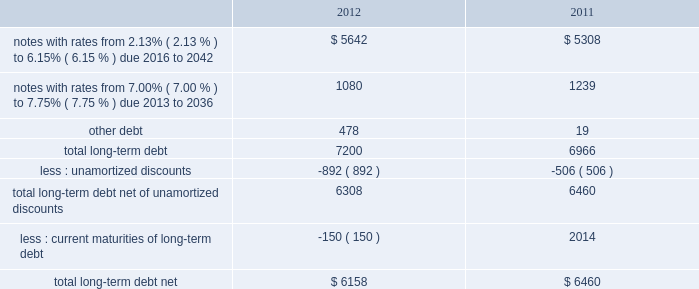Note 8 2013 debt our long-term debt consisted of the following ( in millions ) : .
In december 2012 , we issued notes totaling $ 1.3 billion with a fixed interest rate of 4.07% ( 4.07 % ) maturing in december 2042 ( the new notes ) in exchange for outstanding notes totaling $ 1.2 billion with interest rates ranging from 5.50% ( 5.50 % ) to 8.50% ( 8.50 % ) maturing in 2023 to 2040 ( the old notes ) .
In connection with the exchange , we paid a premium of $ 393 million , of which $ 225 million was paid in cash and $ 168 million was in the form of new notes .
This premium , in addition to $ 194 million in remaining unamortized discounts related to the old notes , will be amortized as additional interest expense over the term of the new notes using the effective interest method .
We may , at our option , redeem some or all of the new notes at any time by paying the principal amount of notes being redeemed plus a make-whole premium and accrued and unpaid interest .
Interest on the new notes is payable on june 15 and december 15 of each year , beginning on june 15 , 2013 .
The new notes are unsecured senior obligations and rank equally in right of payment with all of our existing and future unsecured and unsubordinated indebtedness .
On september 9 , 2011 , we issued $ 2.0 billion of long-term notes in a registered public offering consisting of $ 500 million maturing in 2016 with a fixed interest rate of 2.13% ( 2.13 % ) , $ 900 million maturing in 2021 with a fixed interest rate of 3.35% ( 3.35 % ) , and $ 600 million maturing in 2041 with a fixed interest rate of 4.85% ( 4.85 % ) .
We may , at our option , redeem some or all of the notes at any time by paying the principal amount of notes being redeemed plus a make-whole premium and accrued and unpaid interest .
Interest on the notes is payable on march 15 and september 15 of each year , beginning on march 15 , 2012 .
In october 2011 , we used a portion of the proceeds to redeem all of our $ 500 million long-term notes maturing in 2013 .
In 2011 , we repurchased $ 84 million of our long-term notes through open-market purchases .
We paid premiums of $ 48 million in connection with the early extinguishments of debt , which were recognized in other non-operating income ( expense ) , net .
In august 2011 , we entered into a $ 1.5 billion revolving credit facility with a group of banks and terminated our existing $ 1.5 billion revolving credit facility that was to expire in june 2012 .
The credit facility expires august 2016 , and we may request and the banks may grant , at their discretion , an increase to the credit facility by an additional amount up to $ 500 million .
There were no borrowings outstanding under either facility through december 31 , 2012 .
Borrowings under the credit facility would be unsecured and bear interest at rates based , at our option , on a eurodollar rate or a base rate , as defined in the credit facility .
Each bank 2019s obligation to make loans under the credit facility is subject to , among other things , our compliance with various representations , warranties and covenants , including covenants limiting our ability and certain of our subsidiaries 2019 ability to encumber assets and a covenant not to exceed a maximum leverage ratio , as defined in the credit facility .
The leverage ratio covenant excludes the adjustments recognized in stockholders 2019 equity related to postretirement benefit plans .
As of december 31 , 2012 , we were in compliance with all covenants contained in the credit facility , as well as in our debt agreements .
We have agreements in place with banking institutions to provide for the issuance of commercial paper .
There were no commercial paper borrowings outstanding during 2012 or 2011 .
If we were to issue commercial paper , the borrowings would be supported by the credit facility .
During the next five years , we have scheduled long-term debt maturities of $ 150 million due in 2013 and $ 952 million due in 2016 .
Interest payments were $ 378 million in 2012 , $ 326 million in 2011 , and $ 337 million in 2010. .
What is the percentage change in interest payments from 2011 to 2012? 
Computations: ((378 - 326) / 326)
Answer: 0.15951. 